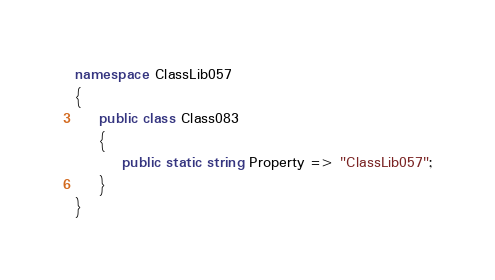Convert code to text. <code><loc_0><loc_0><loc_500><loc_500><_C#_>namespace ClassLib057
{
    public class Class083
    {
        public static string Property => "ClassLib057";
    }
}
</code> 